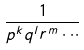Convert formula to latex. <formula><loc_0><loc_0><loc_500><loc_500>\frac { 1 } { p ^ { k } q ^ { l } r ^ { m } \cdot \cdot \cdot }</formula> 